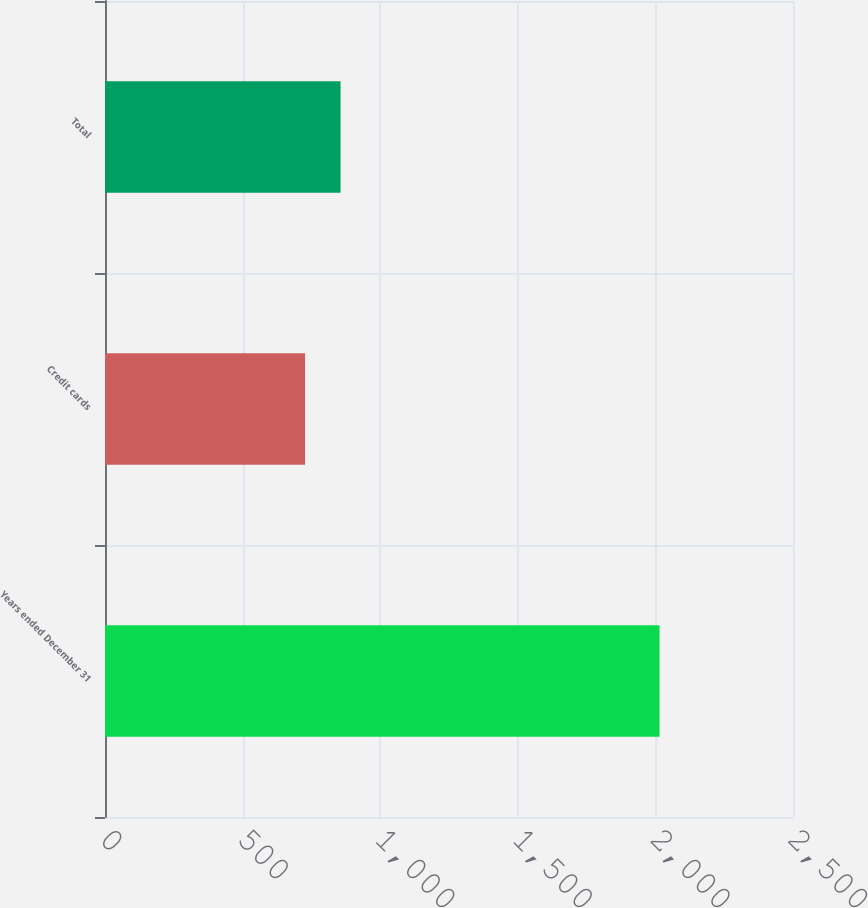<chart> <loc_0><loc_0><loc_500><loc_500><bar_chart><fcel>Years ended December 31<fcel>Credit cards<fcel>Total<nl><fcel>2015<fcel>727<fcel>855.8<nl></chart> 